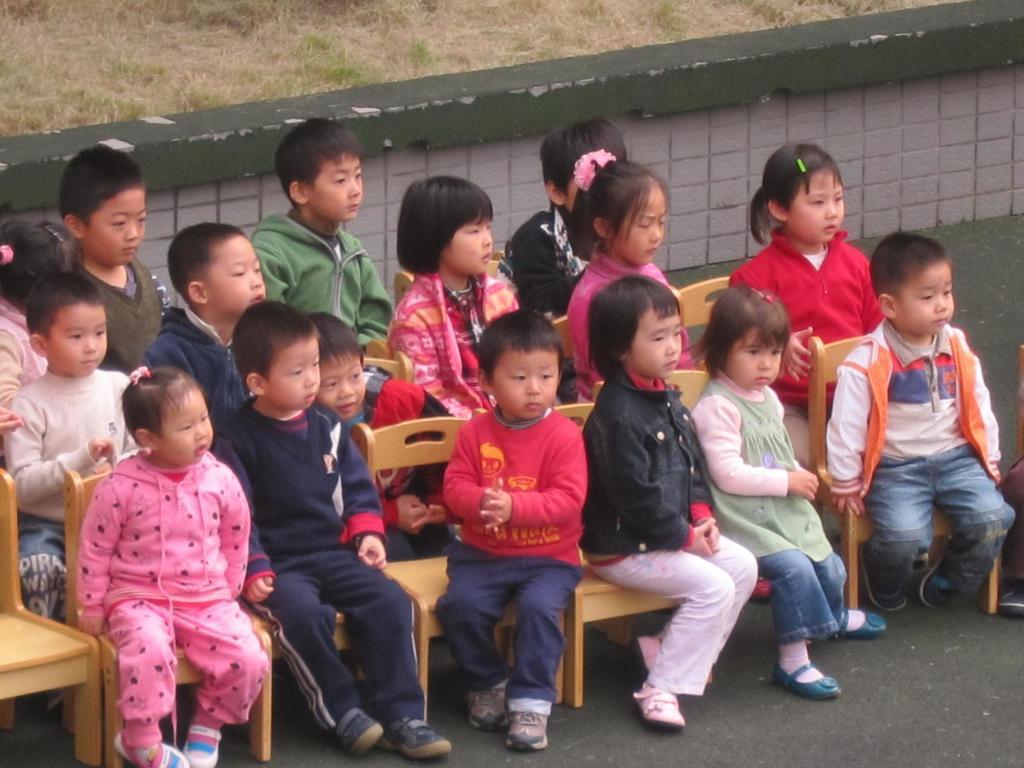How would you summarize this image in a sentence or two? In this image there are few children's sitting on the chairs, behind them there is a wall, behind the wall there is grass. 